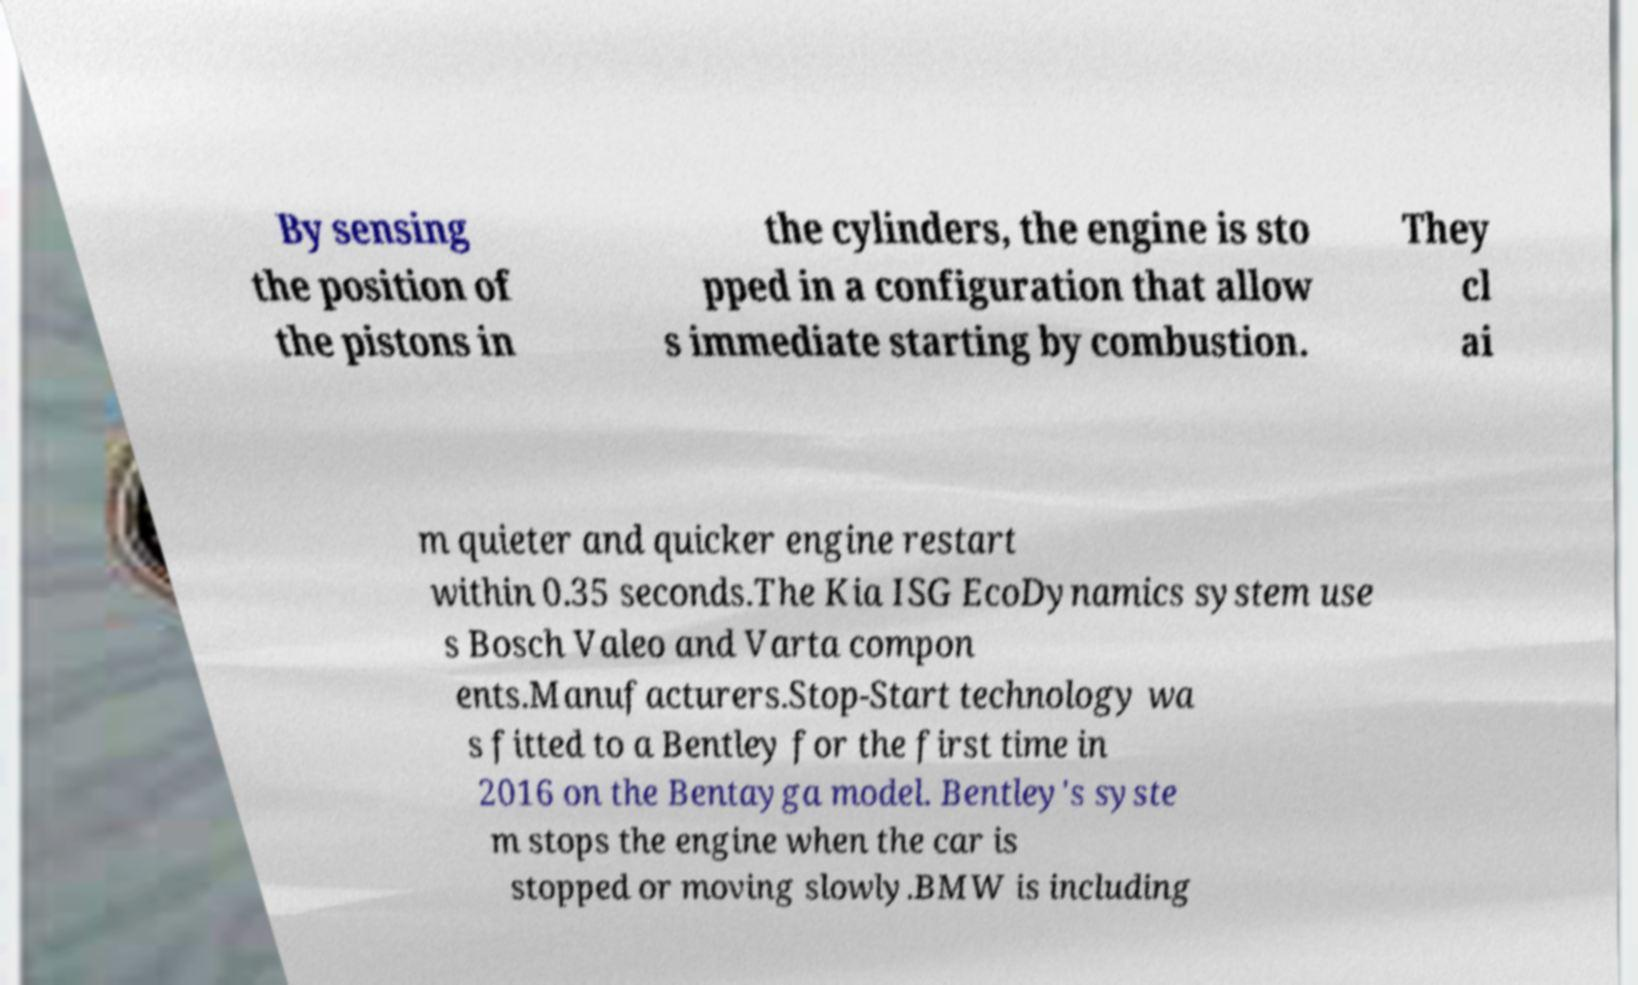Please read and relay the text visible in this image. What does it say? By sensing the position of the pistons in the cylinders, the engine is sto pped in a configuration that allow s immediate starting by combustion. They cl ai m quieter and quicker engine restart within 0.35 seconds.The Kia ISG EcoDynamics system use s Bosch Valeo and Varta compon ents.Manufacturers.Stop-Start technology wa s fitted to a Bentley for the first time in 2016 on the Bentayga model. Bentley's syste m stops the engine when the car is stopped or moving slowly.BMW is including 